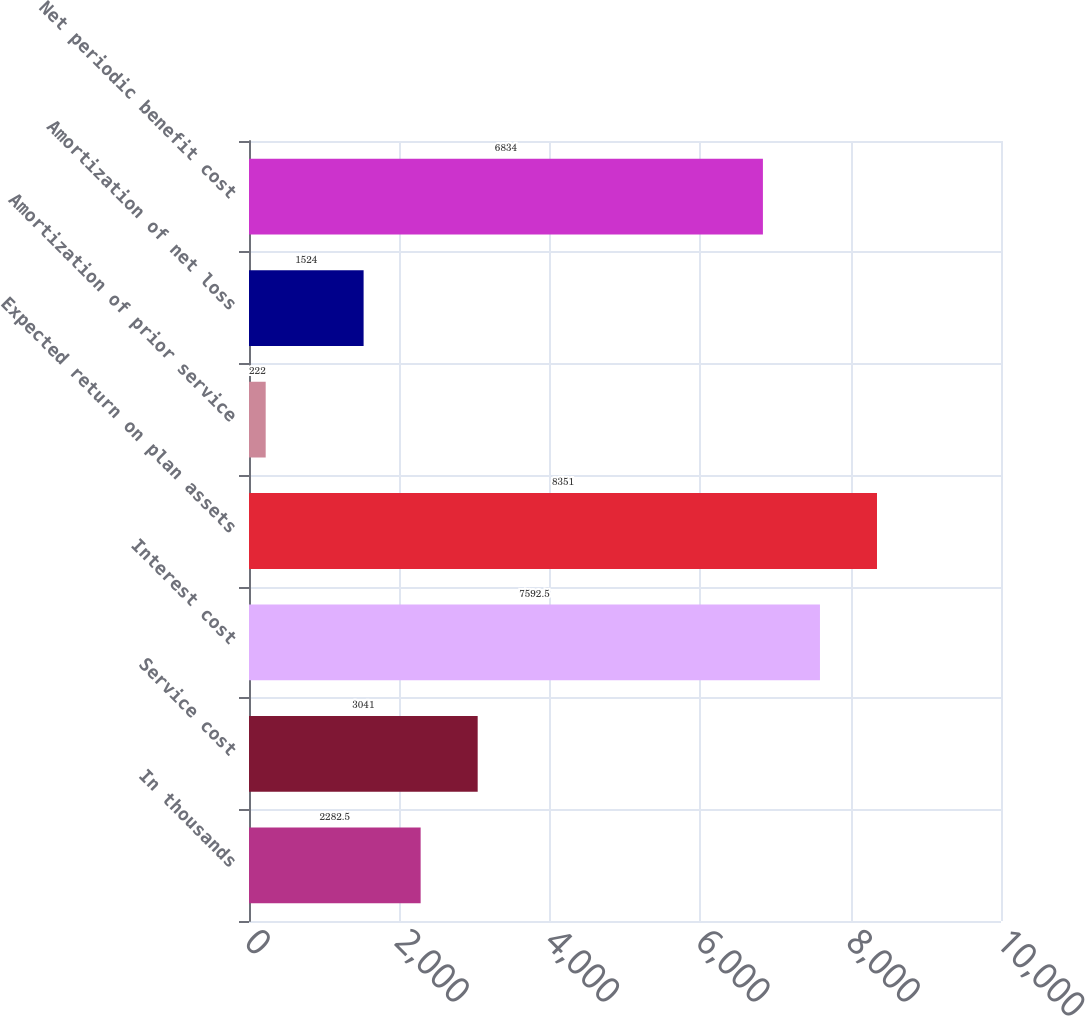Convert chart to OTSL. <chart><loc_0><loc_0><loc_500><loc_500><bar_chart><fcel>In thousands<fcel>Service cost<fcel>Interest cost<fcel>Expected return on plan assets<fcel>Amortization of prior service<fcel>Amortization of net loss<fcel>Net periodic benefit cost<nl><fcel>2282.5<fcel>3041<fcel>7592.5<fcel>8351<fcel>222<fcel>1524<fcel>6834<nl></chart> 